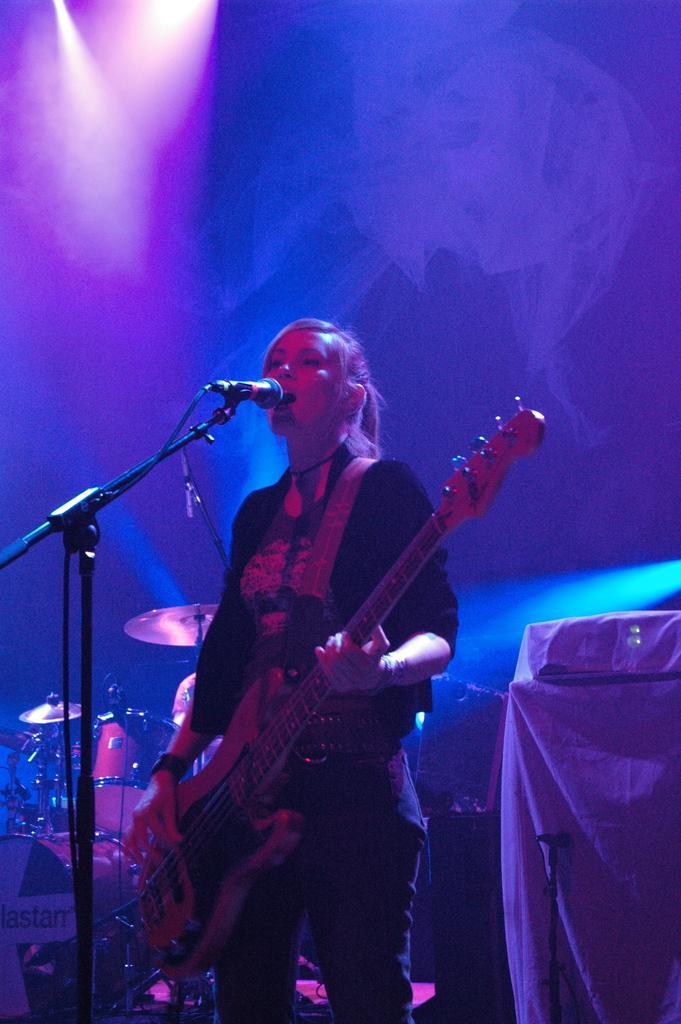Describe this image in one or two sentences. In the image there is a woman playing guitar and singing on mic and behind her there are drums and lights over the ceiling. 